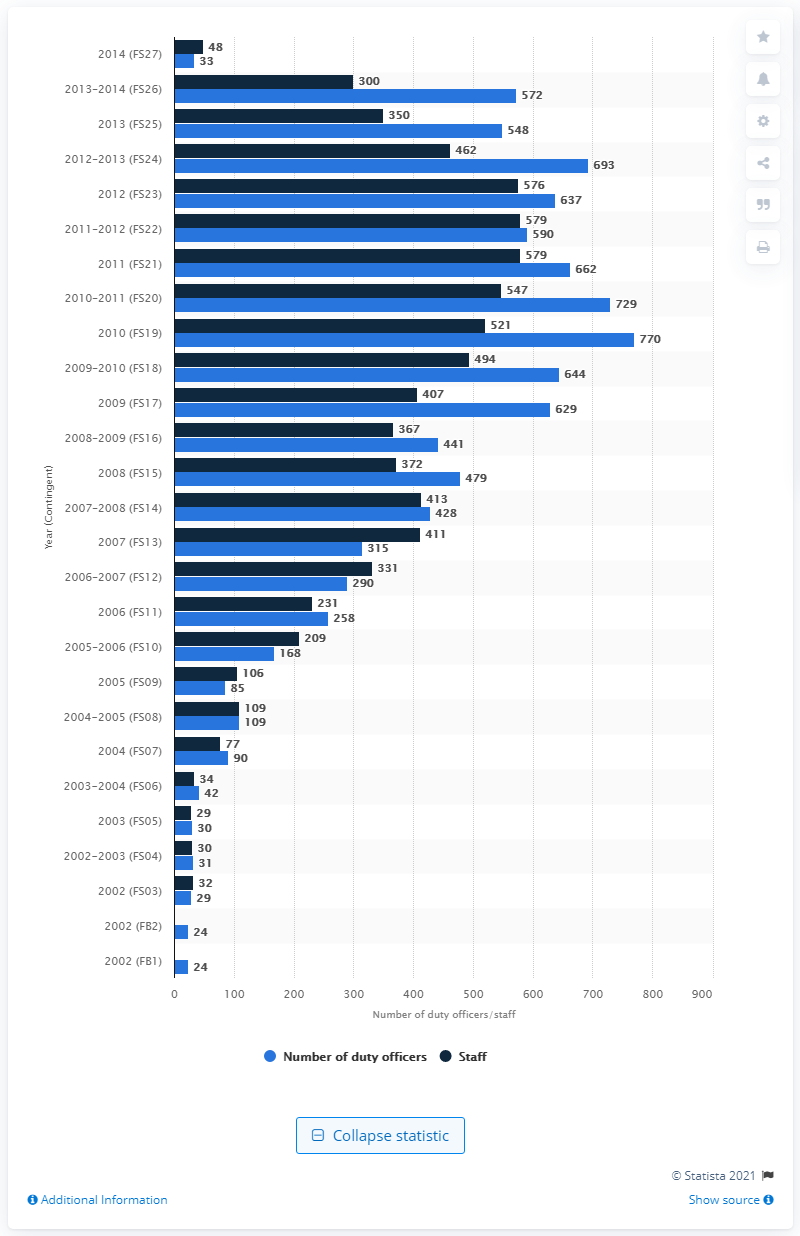Specify some key components in this picture. In 2014, Sweden contributed a total of 33 duty officers to the International Security Assistance Force (ISAF). 